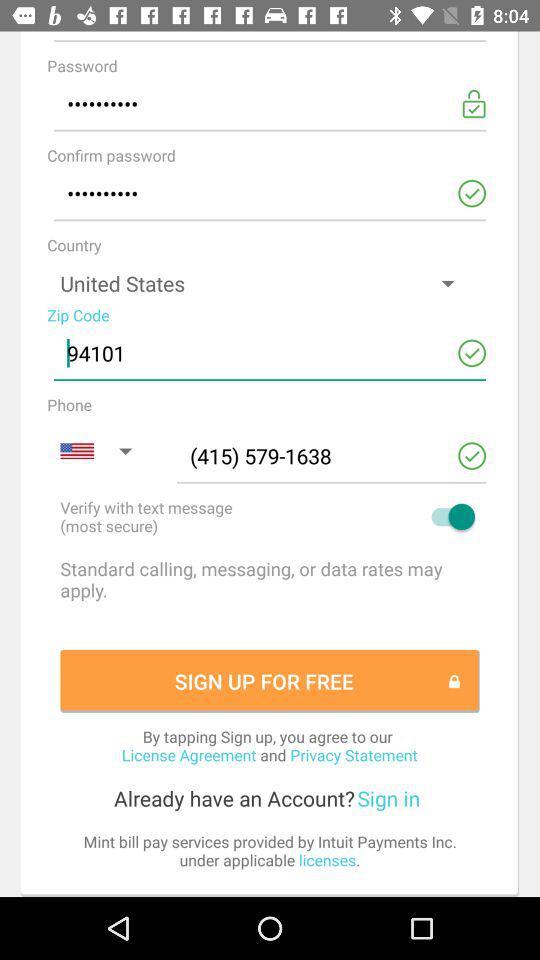What is the phone number? The phone number is (415) 579-1638. 